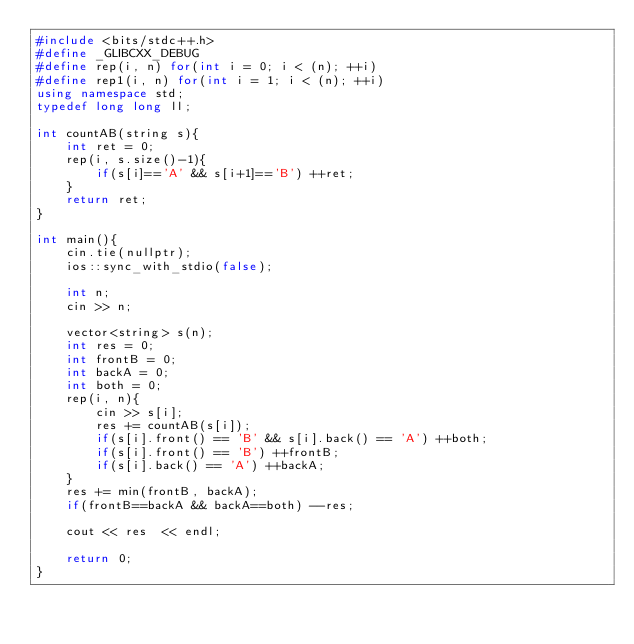Convert code to text. <code><loc_0><loc_0><loc_500><loc_500><_C++_>#include <bits/stdc++.h>
#define _GLIBCXX_DEBUG
#define rep(i, n) for(int i = 0; i < (n); ++i)
#define rep1(i, n) for(int i = 1; i < (n); ++i)
using namespace std;
typedef long long ll;

int countAB(string s){
    int ret = 0;
    rep(i, s.size()-1){
        if(s[i]=='A' && s[i+1]=='B') ++ret;
    }
    return ret;
}

int main(){
    cin.tie(nullptr);
    ios::sync_with_stdio(false);

    int n;
    cin >> n;

    vector<string> s(n);
    int res = 0;
    int frontB = 0;
    int backA = 0;
    int both = 0;
    rep(i, n){
        cin >> s[i];
        res += countAB(s[i]);
        if(s[i].front() == 'B' && s[i].back() == 'A') ++both;
        if(s[i].front() == 'B') ++frontB;
        if(s[i].back() == 'A') ++backA;
    }
    res += min(frontB, backA);
    if(frontB==backA && backA==both) --res;
    
    cout << res  << endl;

    return 0;
}</code> 